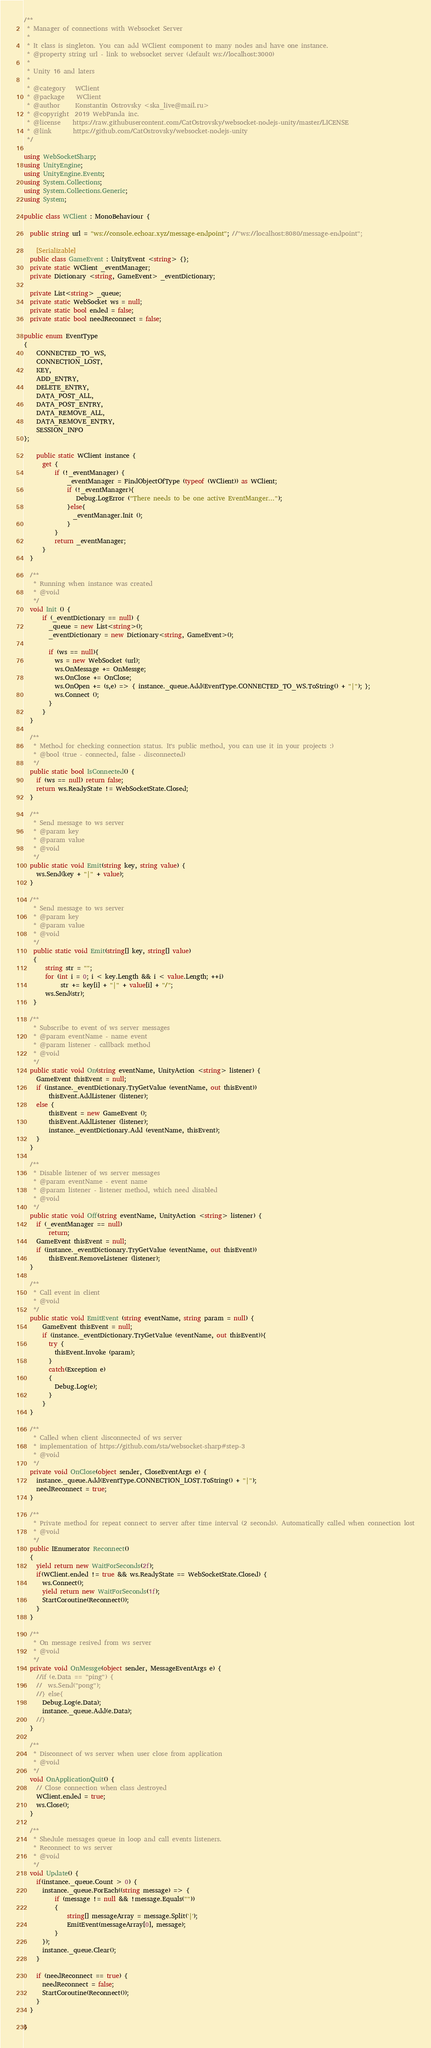<code> <loc_0><loc_0><loc_500><loc_500><_C#_>/**
 * Manager of connections with Websocket Server
 *
 * It class is singleton. You can add WClient component to many nodes and have one instance.
 * @property string url - link to websocket server (default ws://localhost:3000)
 *
 * Unity 16 and laters
 *
 * @category   WClient
 * @package    WClient
 * @author     Konstantin Ostrovsky <ska_live@mail.ru>
 * @copyright  2019 WebPanda inc.
 * @license    https://raw.githubusercontent.com/CatOstrovsky/websocket-nodejs-unity/master/LICENSE
 * @link       https://github.com/CatOstrovsky/websocket-nodejs-unity
 */

using WebSocketSharp;
using UnityEngine;
using UnityEngine.Events;
using System.Collections;
using System.Collections.Generic;
using System;

public class WClient : MonoBehaviour {

  public string url = "ws://console.echoar.xyz/message-endpoint"; //"ws://localhost:8080/message-endpoint";

    [Serializable]
  public class GameEvent : UnityEvent <string> {};
  private static WClient _eventManager;
  private Dictionary <string, GameEvent> _eventDictionary;

  private List<string> _queue;
  private static WebSocket ws = null;
  private static bool ended = false;
  private static bool needReconnect = false;

public enum EventType
{
    CONNECTED_TO_WS,
    CONNECTION_LOST,
    KEY,
    ADD_ENTRY,
    DELETE_ENTRY,
    DATA_POST_ALL,
    DATA_POST_ENTRY,
    DATA_REMOVE_ALL,
    DATA_REMOVE_ENTRY,
    SESSION_INFO
};

    public static WClient instance {
      get {
          if (!_eventManager) {
              _eventManager = FindObjectOfType (typeof (WClient)) as WClient;
              if (!_eventManager){
                 Debug.LogError ("There needs to be one active EventManger...");
              }else{
                _eventManager.Init ();
              }
          }
          return _eventManager;
      }
  }

  /**
   * Running when instance was created
   * @void
   */
  void Init () {
      if (_eventDictionary == null) {
        _queue = new List<string>();
        _eventDictionary = new Dictionary<string, GameEvent>();

        if (ws == null){
          ws = new WebSocket (url);
          ws.OnMessage += OnMessge;
          ws.OnClose += OnClose;
          ws.OnOpen += (s,e) => { instance._queue.Add(EventType.CONNECTED_TO_WS.ToString() + "|"); };
          ws.Connect ();
        }
      }
  }

  /**
   * Method for checking connection status. It's public method, you can use it in your projects :)
   * @bool (true - connected, false - disconnected)
   */
  public static bool IsConnected() {
    if (ws == null) return false;
    return ws.ReadyState != WebSocketState.Closed;
  }

  /**
   * Send message to ws server
   * @param key
   * @param value
   * @void
   */
  public static void Emit(string key, string value) {
    ws.Send(key + "|" + value);
  }

  /**
   * Send message to ws server
   * @param key
   * @param value
   * @void
   */
   public static void Emit(string[] key, string[] value)
   {
       string str = "";
       for (int i = 0; i < key.Length && i < value.Length; ++i)
            str += key[i] + "|" + value[i] + "/";
       ws.Send(str);
   }

  /**
   * Subscribe to event of ws server messages
   * @param eventName - name event
   * @param listener - callback method
   * @void
   */
  public static void On(string eventName, UnityAction <string> listener) {
    GameEvent thisEvent = null;
    if (instance._eventDictionary.TryGetValue (eventName, out thisEvent))
        thisEvent.AddListener (listener);
    else {
        thisEvent = new GameEvent ();
        thisEvent.AddListener (listener);
        instance._eventDictionary.Add (eventName, thisEvent);
    }
  }

  /**
   * Disable listener of ws server messages
   * @param eventName - event name
   * @param listener - listener method, which need disabled
   * @void
   */
  public static void Off(string eventName, UnityAction <string> listener) {
    if (_eventManager == null)
        return;
    GameEvent thisEvent = null;
    if (instance._eventDictionary.TryGetValue (eventName, out thisEvent))
        thisEvent.RemoveListener (listener);
  }

  /**
   * Call event in client
   * @void
   */
  public static void EmitEvent (string eventName, string param = null) {
      GameEvent thisEvent = null;
      if (instance._eventDictionary.TryGetValue (eventName, out thisEvent)){
        try {
          thisEvent.Invoke (param);
        }
        catch(Exception e)
        {
          Debug.Log(e);
        }
      }
  }

  /**
   * Called when client disconnected of ws server
   * implementation of https://github.com/sta/websocket-sharp#step-3
   * @void
   */
  private void OnClose(object sender, CloseEventArgs e) {
    instance._queue.Add(EventType.CONNECTION_LOST.ToString() + "|");
    needReconnect = true;
  }

  /**
   * Private method for repeat connect to server after time interval (2 seconds). Automatically called when connection lost
   * @void
   */
  public IEnumerator Reconnect()
  {
    yield return new WaitForSeconds(2f);
    if(WClient.ended != true && ws.ReadyState == WebSocketState.Closed) {
      ws.Connect();
      yield return new WaitForSeconds(1f);
      StartCoroutine(Reconnect());
    }
  }

  /**
   * On message resived from ws server
   * @void
   */
  private void OnMessge(object sender, MessageEventArgs e) {
    //if (e.Data == "ping") {
    //  ws.Send("pong");
    //} else{
      Debug.Log(e.Data);
      instance._queue.Add(e.Data);
    //}
  }

  /**
   * Disconnect of ws server when user close from application
   * @void
   */
  void OnApplicationQuit() {
    // Close connection when class destroyed
    WClient.ended = true;
    ws.Close();
  }

  /**
   * Shedule messages queue in loop and call events listeners.
   * Reconnect to ws server
   * @void
   */
  void Update() {
    if(instance._queue.Count > 0) {
      instance._queue.ForEach((string message) => {
          if (message != null && !message.Equals(""))
          {
              string[] messageArray = message.Split('|');
              EmitEvent(messageArray[0], message);
          }
      });
      instance._queue.Clear();
    }

    if (needReconnect == true) {
      needReconnect = false;
      StartCoroutine(Reconnect());
    }
  }

}
</code> 